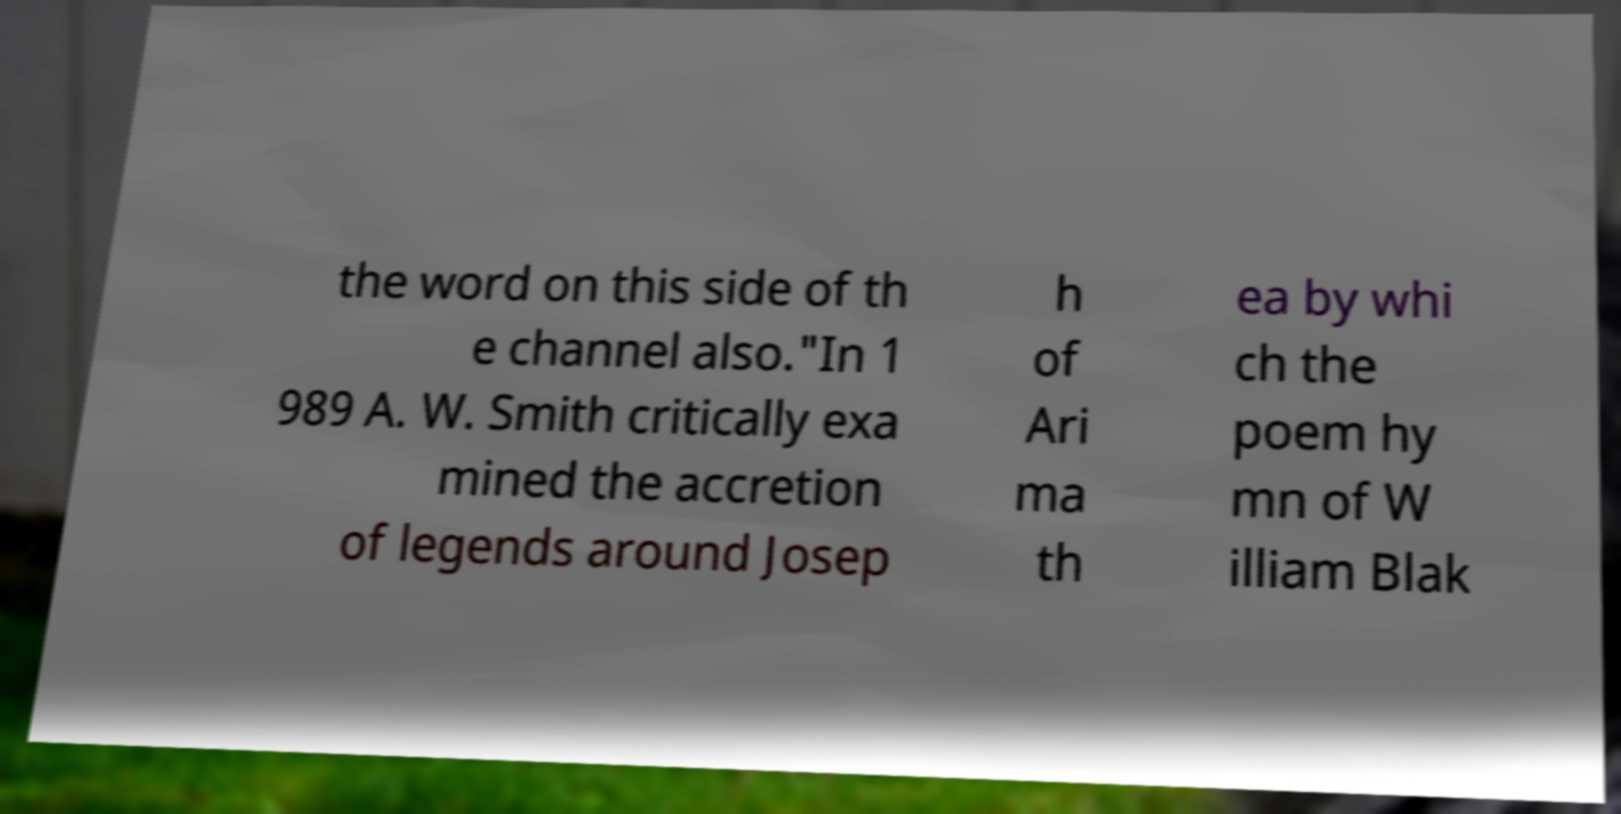Could you assist in decoding the text presented in this image and type it out clearly? the word on this side of th e channel also."In 1 989 A. W. Smith critically exa mined the accretion of legends around Josep h of Ari ma th ea by whi ch the poem hy mn of W illiam Blak 